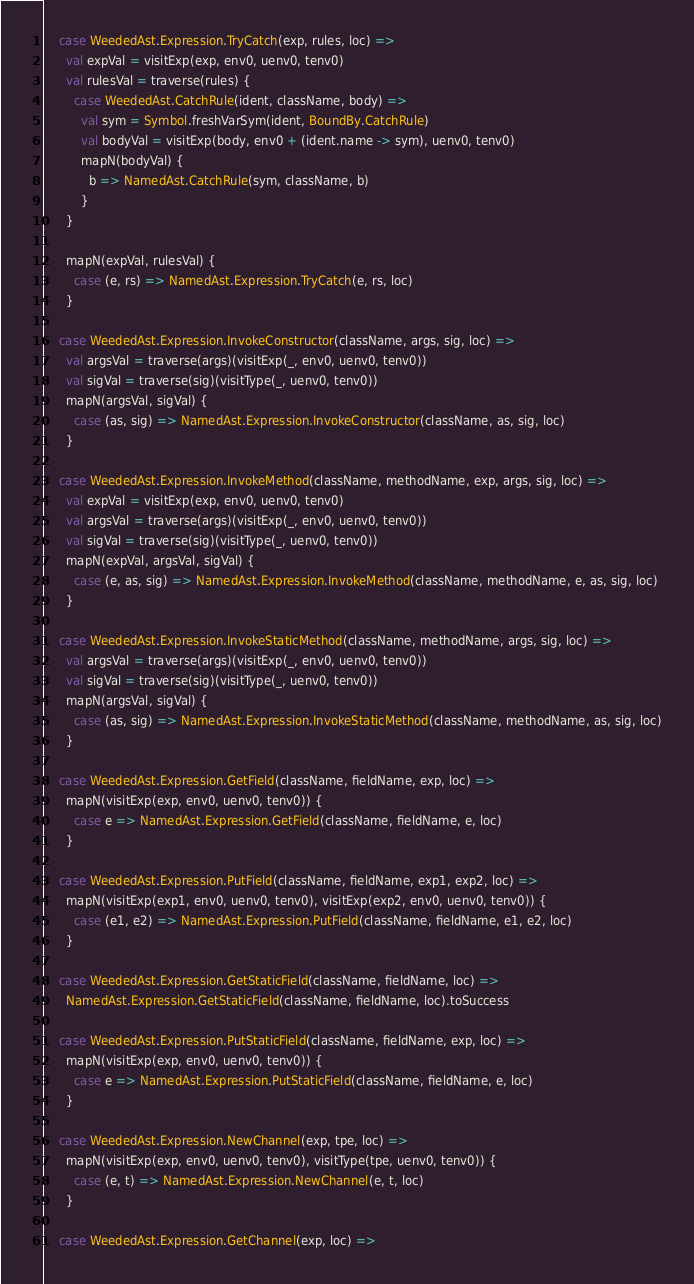Convert code to text. <code><loc_0><loc_0><loc_500><loc_500><_Scala_>
    case WeededAst.Expression.TryCatch(exp, rules, loc) =>
      val expVal = visitExp(exp, env0, uenv0, tenv0)
      val rulesVal = traverse(rules) {
        case WeededAst.CatchRule(ident, className, body) =>
          val sym = Symbol.freshVarSym(ident, BoundBy.CatchRule)
          val bodyVal = visitExp(body, env0 + (ident.name -> sym), uenv0, tenv0)
          mapN(bodyVal) {
            b => NamedAst.CatchRule(sym, className, b)
          }
      }

      mapN(expVal, rulesVal) {
        case (e, rs) => NamedAst.Expression.TryCatch(e, rs, loc)
      }

    case WeededAst.Expression.InvokeConstructor(className, args, sig, loc) =>
      val argsVal = traverse(args)(visitExp(_, env0, uenv0, tenv0))
      val sigVal = traverse(sig)(visitType(_, uenv0, tenv0))
      mapN(argsVal, sigVal) {
        case (as, sig) => NamedAst.Expression.InvokeConstructor(className, as, sig, loc)
      }

    case WeededAst.Expression.InvokeMethod(className, methodName, exp, args, sig, loc) =>
      val expVal = visitExp(exp, env0, uenv0, tenv0)
      val argsVal = traverse(args)(visitExp(_, env0, uenv0, tenv0))
      val sigVal = traverse(sig)(visitType(_, uenv0, tenv0))
      mapN(expVal, argsVal, sigVal) {
        case (e, as, sig) => NamedAst.Expression.InvokeMethod(className, methodName, e, as, sig, loc)
      }

    case WeededAst.Expression.InvokeStaticMethod(className, methodName, args, sig, loc) =>
      val argsVal = traverse(args)(visitExp(_, env0, uenv0, tenv0))
      val sigVal = traverse(sig)(visitType(_, uenv0, tenv0))
      mapN(argsVal, sigVal) {
        case (as, sig) => NamedAst.Expression.InvokeStaticMethod(className, methodName, as, sig, loc)
      }

    case WeededAst.Expression.GetField(className, fieldName, exp, loc) =>
      mapN(visitExp(exp, env0, uenv0, tenv0)) {
        case e => NamedAst.Expression.GetField(className, fieldName, e, loc)
      }

    case WeededAst.Expression.PutField(className, fieldName, exp1, exp2, loc) =>
      mapN(visitExp(exp1, env0, uenv0, tenv0), visitExp(exp2, env0, uenv0, tenv0)) {
        case (e1, e2) => NamedAst.Expression.PutField(className, fieldName, e1, e2, loc)
      }

    case WeededAst.Expression.GetStaticField(className, fieldName, loc) =>
      NamedAst.Expression.GetStaticField(className, fieldName, loc).toSuccess

    case WeededAst.Expression.PutStaticField(className, fieldName, exp, loc) =>
      mapN(visitExp(exp, env0, uenv0, tenv0)) {
        case e => NamedAst.Expression.PutStaticField(className, fieldName, e, loc)
      }

    case WeededAst.Expression.NewChannel(exp, tpe, loc) =>
      mapN(visitExp(exp, env0, uenv0, tenv0), visitType(tpe, uenv0, tenv0)) {
        case (e, t) => NamedAst.Expression.NewChannel(e, t, loc)
      }

    case WeededAst.Expression.GetChannel(exp, loc) =></code> 